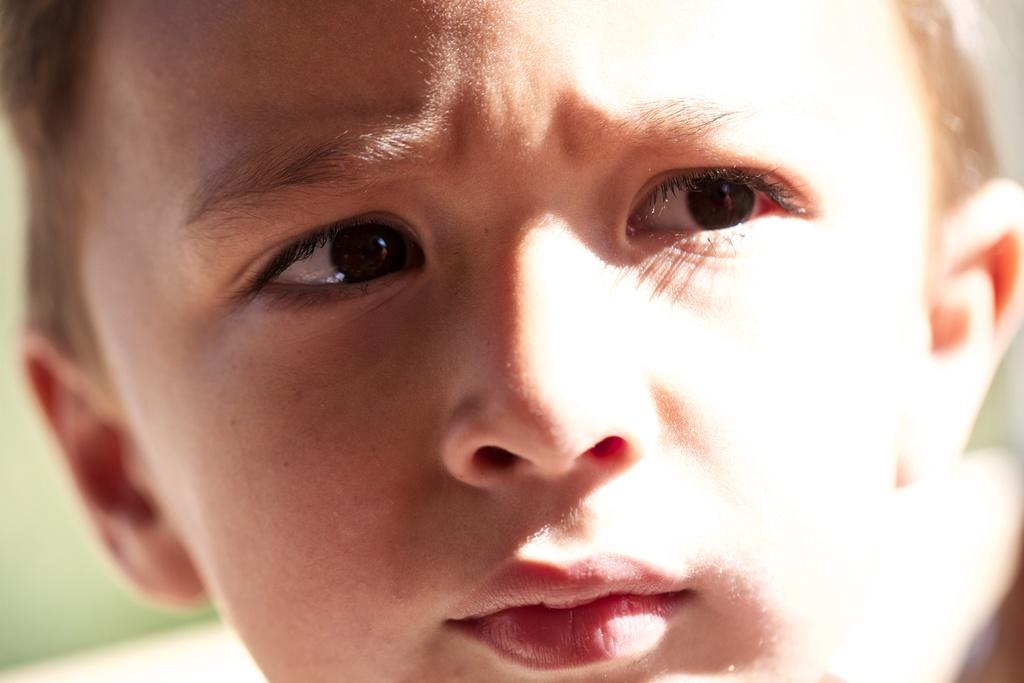How would you summarize this image in a sentence or two? In this image I can see the person's face and I can see the blurred background. 